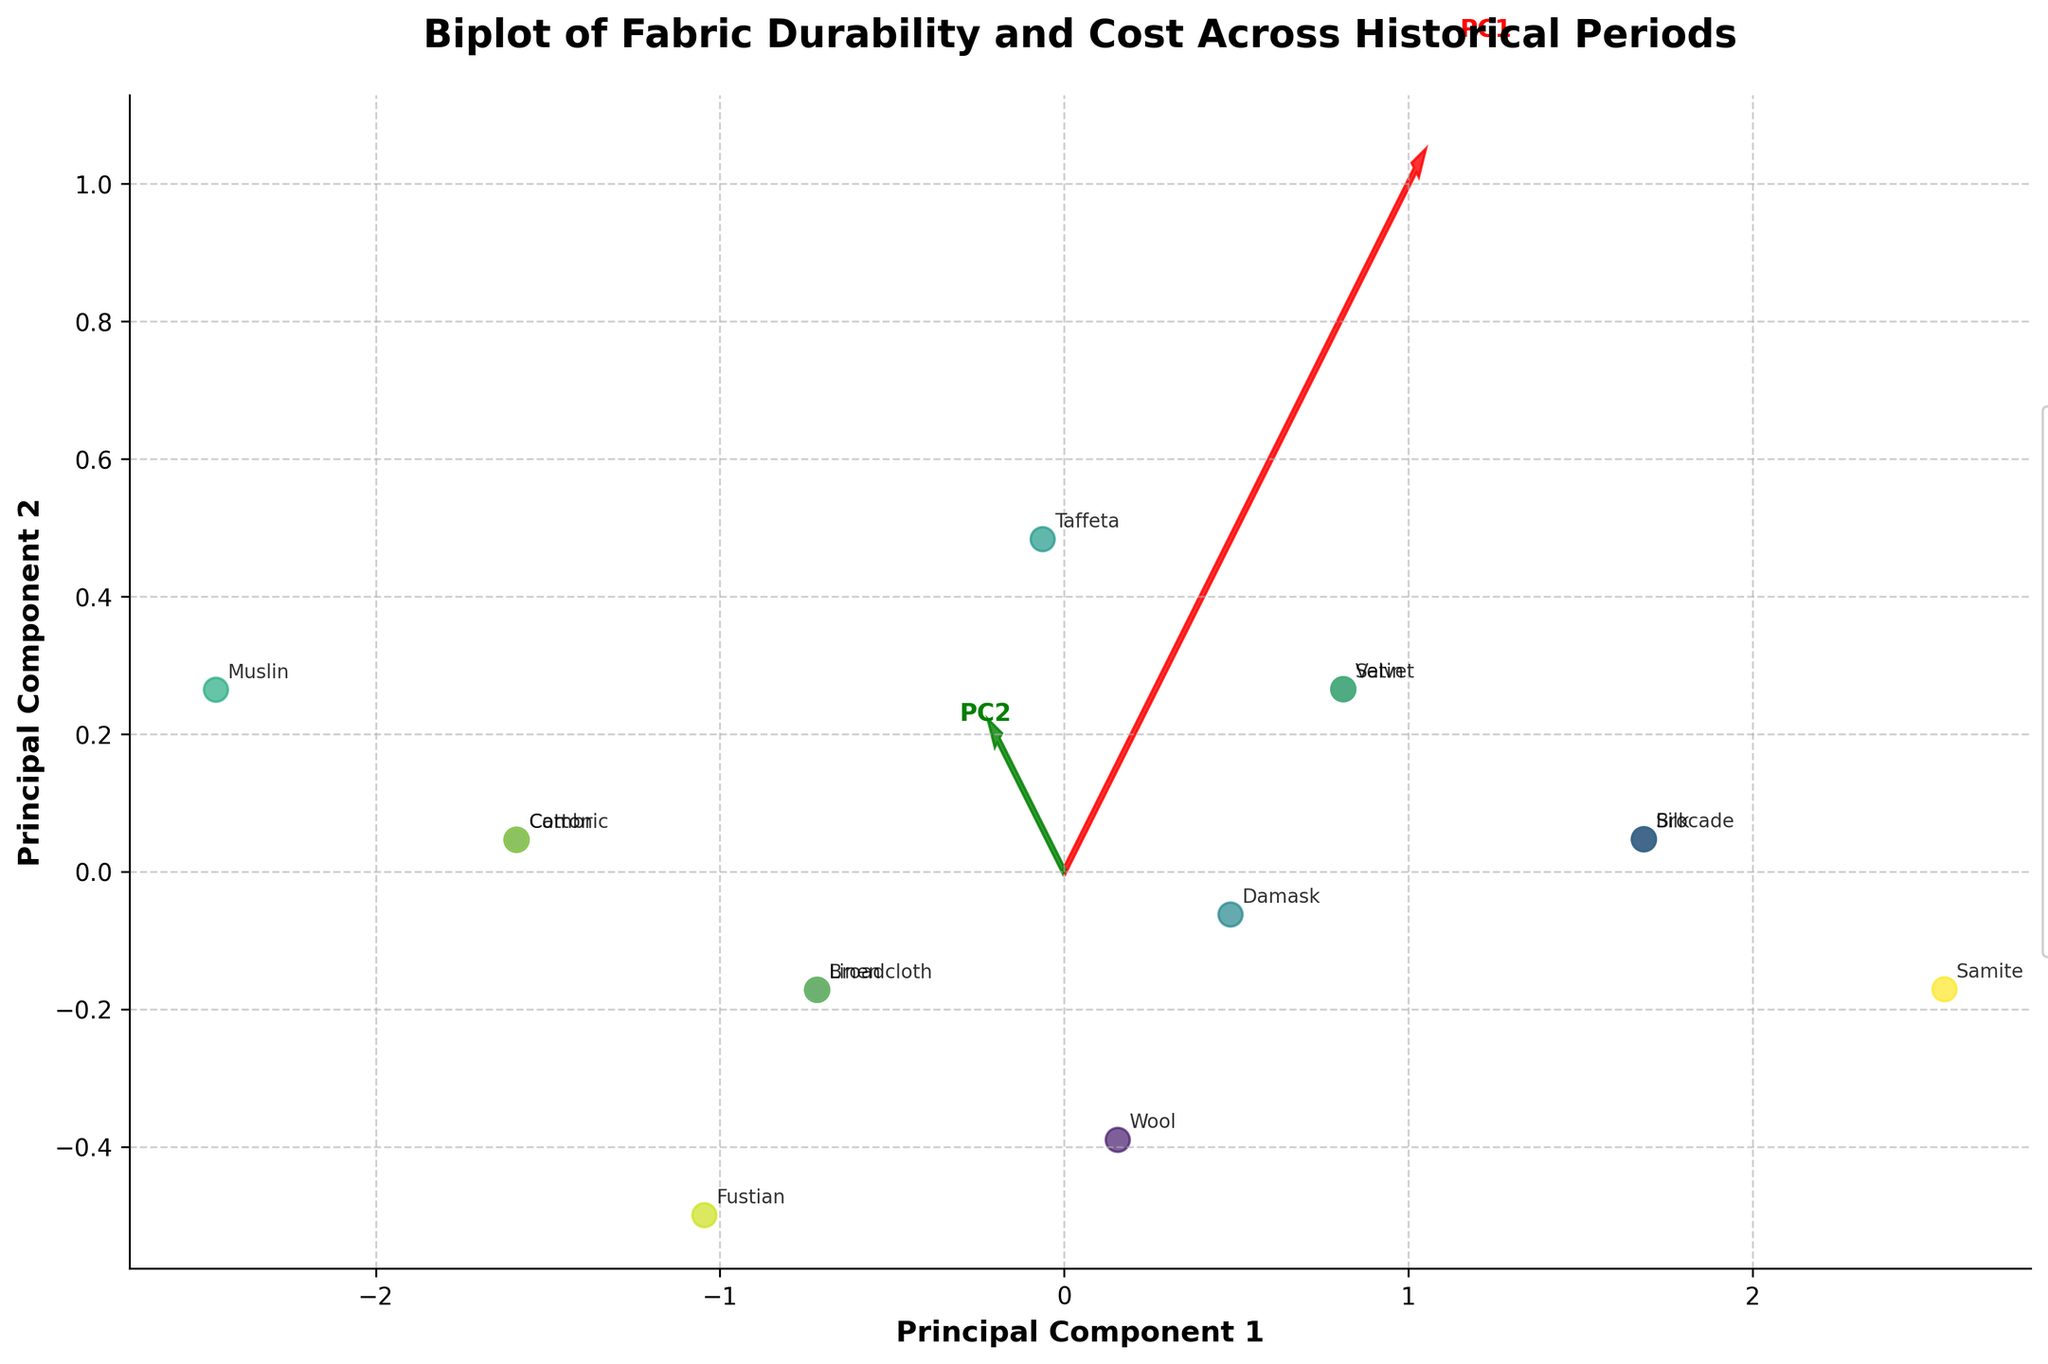What are the axes labeled as? The x-axis is labeled "Principal Component 1," and the y-axis is labeled "Principal Component 2." These are the primary components derived from PCA analysis that represent the major variation patterns in the data.
Answer: Principal Component 1 and Principal Component 2 How many historical periods are represented in the plot? From the legend on the right side of the plot, you can see distinct entries listing all the historical periods. Counting them gives the total number of historical periods depicted.
Answer: 13 Which fabric has the highest combination of durability and cost? Look at the data points on the biplot and locate "Samite" since it is known from the data to have the highest scores in both dimensions. It is positioned furthest away along both principal components.
Answer: Samite Which historical period's fabrics are most closely clustered together? Observe the data points that are close together and refer to their labels. Identify the historical period that appears most clustered compared to others.
Answer: [Based on the plot, you need to look at the clustering and identify a period, e.g., "Regency"] Are there any fabrics that are outliers in terms of both principal components? By visually scanning the plot, locate fabrics that are far removed from the cluster center. Compare their positions to the rest.
Answer: [Identify any outliers based on plot positions] Which principal component seems to reflect durability more? Examine the eigenvector arrows. The one aligned more closely with the direction of most durability data points would reflect durability more.
Answer: PC1 or PC2 [Depending on visual analysis] Which fabrics appear most similar in terms of durability and cost? Locate data points that are close to each other on the biplot and identify their fabric labels.
Answer: [Identify similar fabrics based on proximity] Which historical period shows fabrics with the highest cost variability? Look for the spread of data points from the same historical period along the cost dimension, PC2.
Answer: [Identify based on visual spread, e.g., "Renaissance"] Which fabric has a lower cost but higher durability compared to Satin? Find the position of Satin and look for any fabric positioned lower on the cost axis but higher on durability. Cross-check with labels.
Answer: [Specific fabric name based on visual analysis] Is there a clear separation between fabrics from different historical periods in the principal component space? Inspect the plot to see if data groups from different historical periods are distinctly separated or significantly overlap.
Answer: Yes/No [Depending on visual observation] 